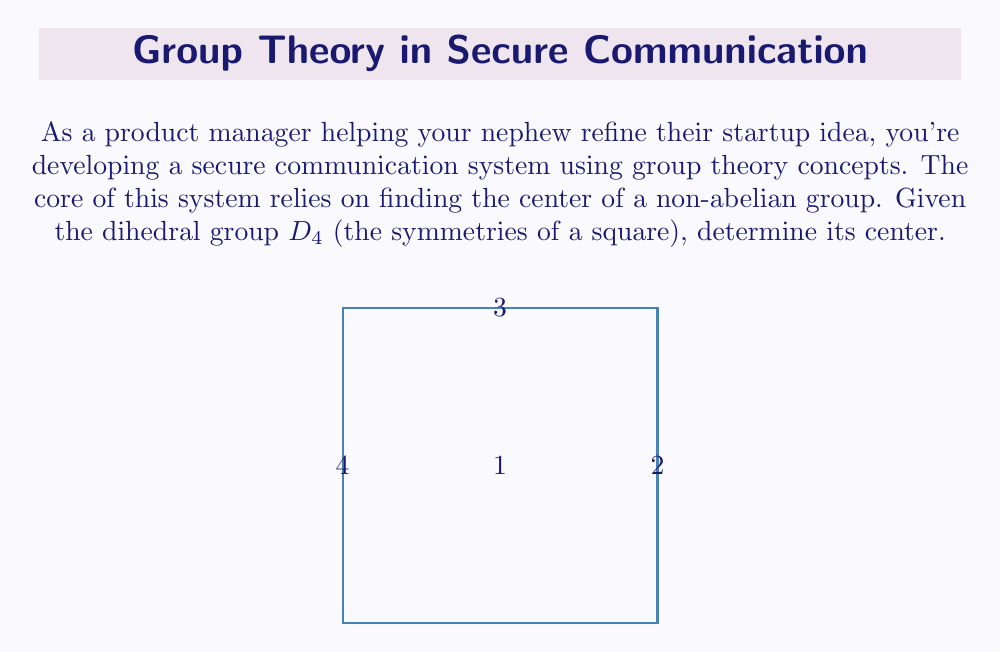Could you help me with this problem? To find the center of $D_4$, we need to follow these steps:

1) Recall that the center of a group $G$ is defined as:
   $$Z(G) = \{z \in G : zg = gz \text{ for all } g \in G\}$$

2) $D_4$ has 8 elements: 
   - Identity (e)
   - 90° rotations (r, r², r³)
   - Reflections (s, sr, sr², sr³)

3) We need to check which elements commute with all others:

   a) The identity e commutes with everything.
   
   b) For rotations:
      - r² (180° rotation) commutes with everything.
      - r and r³ don't commute with reflections.
   
   c) Reflections don't commute with rotations (except e and r²).

4) Therefore, only e and r² commute with all elements of $D_4$.

5) Thus, the center of $D_4$ is $Z(D_4) = \{e, r²\}$.

This subgroup represents the rotational symmetry that leaves the square unchanged (0° and 180° rotations).
Answer: $Z(D_4) = \{e, r²\}$ 